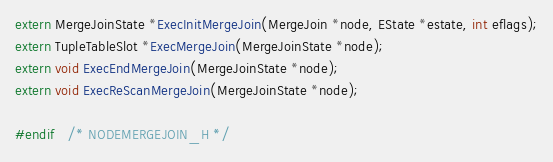<code> <loc_0><loc_0><loc_500><loc_500><_C_>
extern MergeJoinState *ExecInitMergeJoin(MergeJoin *node, EState *estate, int eflags);
extern TupleTableSlot *ExecMergeJoin(MergeJoinState *node);
extern void ExecEndMergeJoin(MergeJoinState *node);
extern void ExecReScanMergeJoin(MergeJoinState *node);

#endif   /* NODEMERGEJOIN_H */
</code> 